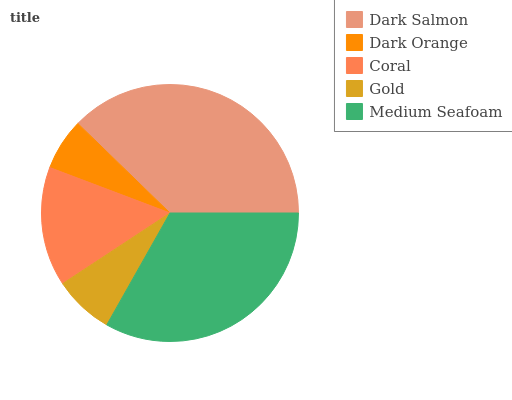Is Dark Orange the minimum?
Answer yes or no. Yes. Is Dark Salmon the maximum?
Answer yes or no. Yes. Is Coral the minimum?
Answer yes or no. No. Is Coral the maximum?
Answer yes or no. No. Is Coral greater than Dark Orange?
Answer yes or no. Yes. Is Dark Orange less than Coral?
Answer yes or no. Yes. Is Dark Orange greater than Coral?
Answer yes or no. No. Is Coral less than Dark Orange?
Answer yes or no. No. Is Coral the high median?
Answer yes or no. Yes. Is Coral the low median?
Answer yes or no. Yes. Is Medium Seafoam the high median?
Answer yes or no. No. Is Gold the low median?
Answer yes or no. No. 